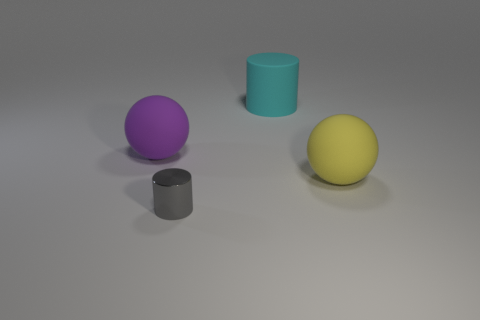Are there an equal number of yellow matte spheres behind the large purple rubber object and gray blocks?
Give a very brief answer. Yes. Is the shape of the purple rubber thing the same as the tiny gray metallic object?
Ensure brevity in your answer.  No. Is there anything else of the same color as the large cylinder?
Give a very brief answer. No. What shape is the thing that is both behind the gray metal cylinder and in front of the purple sphere?
Make the answer very short. Sphere. Are there an equal number of large matte objects to the left of the tiny object and cyan matte cylinders in front of the big matte cylinder?
Ensure brevity in your answer.  No. How many blocks are big yellow rubber things or purple objects?
Your answer should be compact. 0. What number of yellow balls are the same material as the large purple ball?
Offer a terse response. 1. There is a big object that is both in front of the large cyan matte thing and on the left side of the yellow thing; what is its material?
Provide a short and direct response. Rubber. The large purple matte thing that is to the left of the large cyan thing has what shape?
Keep it short and to the point. Sphere. What shape is the large object in front of the large thing that is to the left of the big cyan thing?
Your response must be concise. Sphere. 